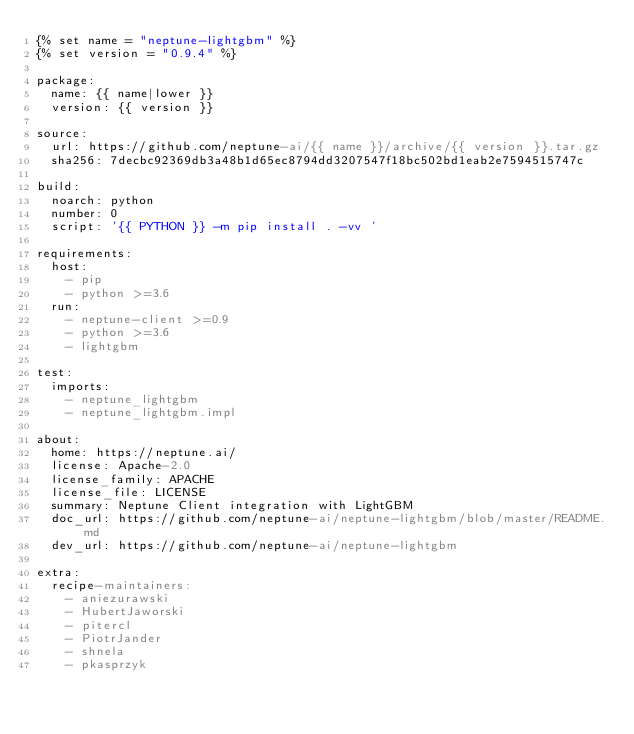Convert code to text. <code><loc_0><loc_0><loc_500><loc_500><_YAML_>{% set name = "neptune-lightgbm" %}
{% set version = "0.9.4" %}

package:
  name: {{ name|lower }}
  version: {{ version }}

source:
  url: https://github.com/neptune-ai/{{ name }}/archive/{{ version }}.tar.gz
  sha256: 7decbc92369db3a48b1d65ec8794dd3207547f18bc502bd1eab2e7594515747c

build:
  noarch: python
  number: 0
  script: '{{ PYTHON }} -m pip install . -vv '

requirements:
  host:
    - pip
    - python >=3.6
  run:
    - neptune-client >=0.9
    - python >=3.6
    - lightgbm

test:
  imports:
    - neptune_lightgbm
    - neptune_lightgbm.impl

about:
  home: https://neptune.ai/
  license: Apache-2.0
  license_family: APACHE
  license_file: LICENSE
  summary: Neptune Client integration with LightGBM
  doc_url: https://github.com/neptune-ai/neptune-lightgbm/blob/master/README.md
  dev_url: https://github.com/neptune-ai/neptune-lightgbm

extra:
  recipe-maintainers:
    - aniezurawski
    - HubertJaworski
    - pitercl
    - PiotrJander
    - shnela
    - pkasprzyk
</code> 